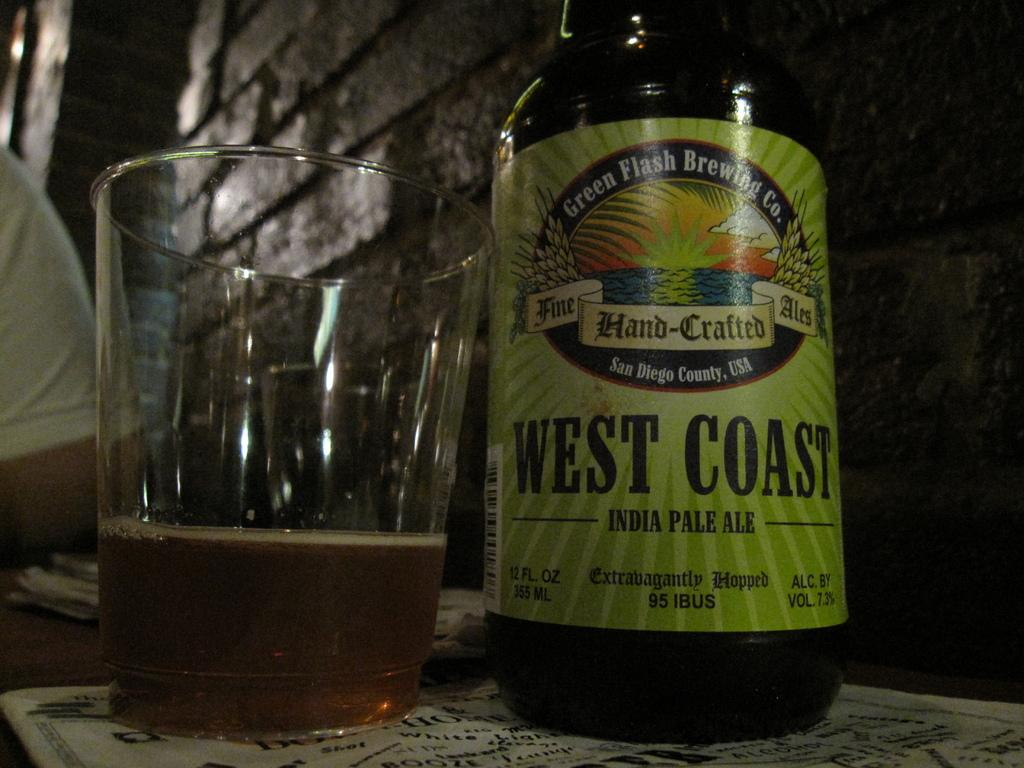<image>
Present a compact description of the photo's key features. A glass and bottle of West Coast India Pale Ale. 